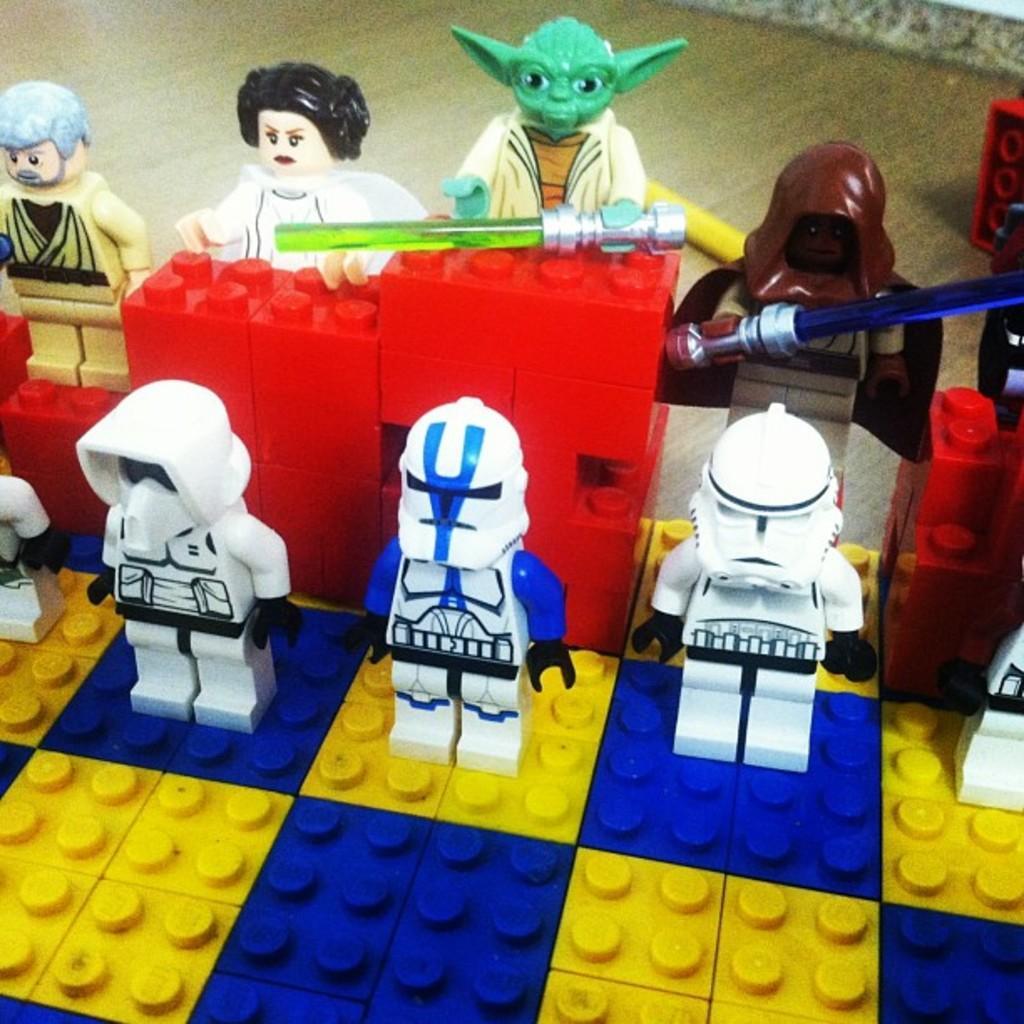Please provide a concise description of this image. In this picture we can see LEGO toys in the front, it looks like floor at the bottom. 